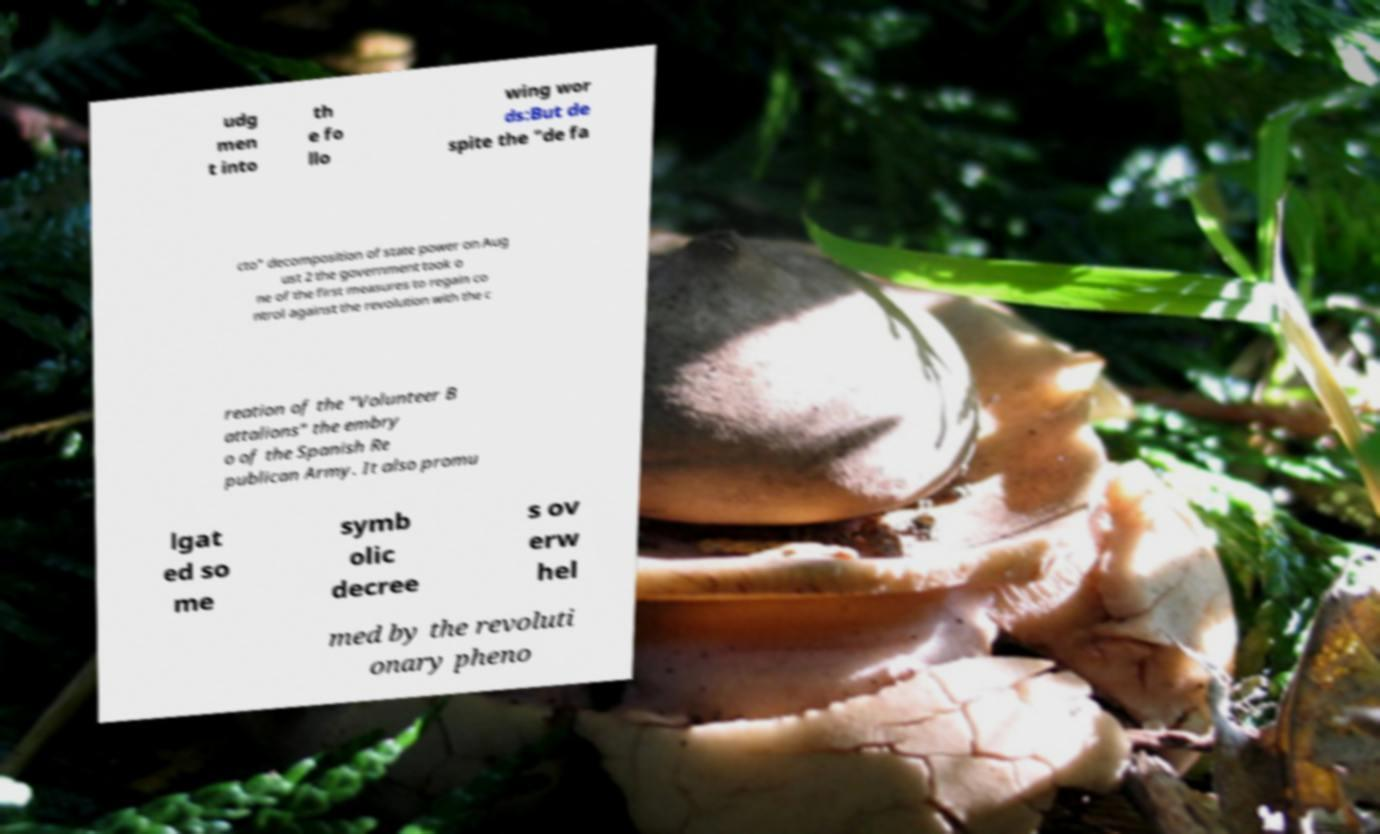Could you assist in decoding the text presented in this image and type it out clearly? udg men t into th e fo llo wing wor ds:But de spite the "de fa cto" decomposition of state power on Aug ust 2 the government took o ne of the first measures to regain co ntrol against the revolution with the c reation of the "Volunteer B attalions" the embry o of the Spanish Re publican Army. It also promu lgat ed so me symb olic decree s ov erw hel med by the revoluti onary pheno 